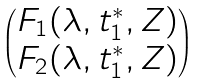Convert formula to latex. <formula><loc_0><loc_0><loc_500><loc_500>\begin{pmatrix} F _ { 1 } ( \lambda , t _ { 1 } ^ { * } , Z ) \\ F _ { 2 } ( \lambda , t _ { 1 } ^ { * } , Z ) \end{pmatrix}</formula> 